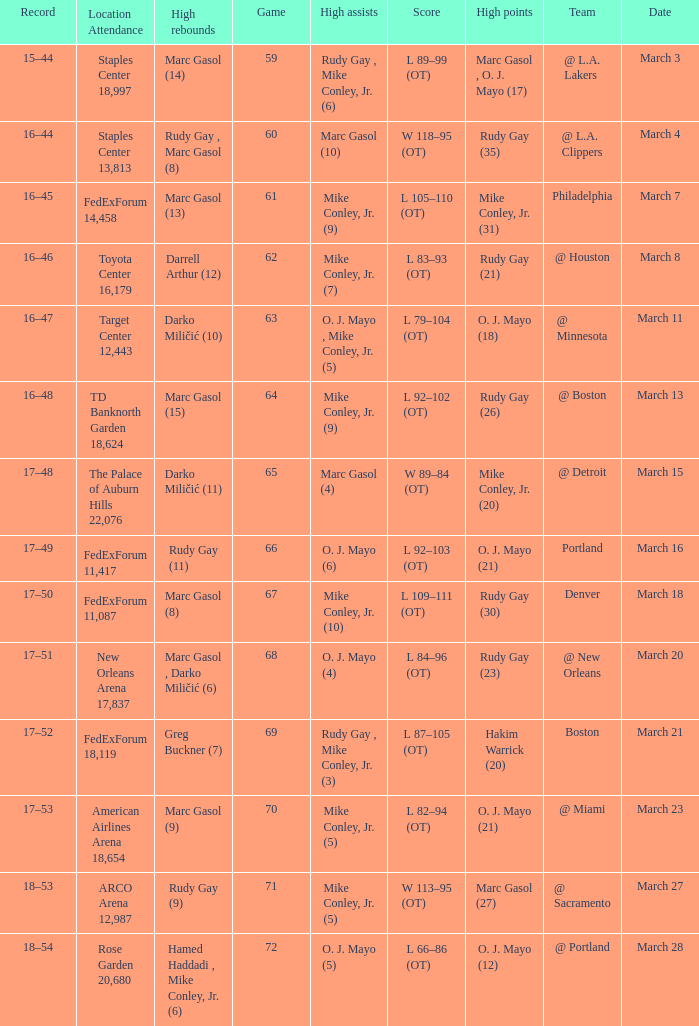What was the location and attendance for game 60? Staples Center 13,813. 